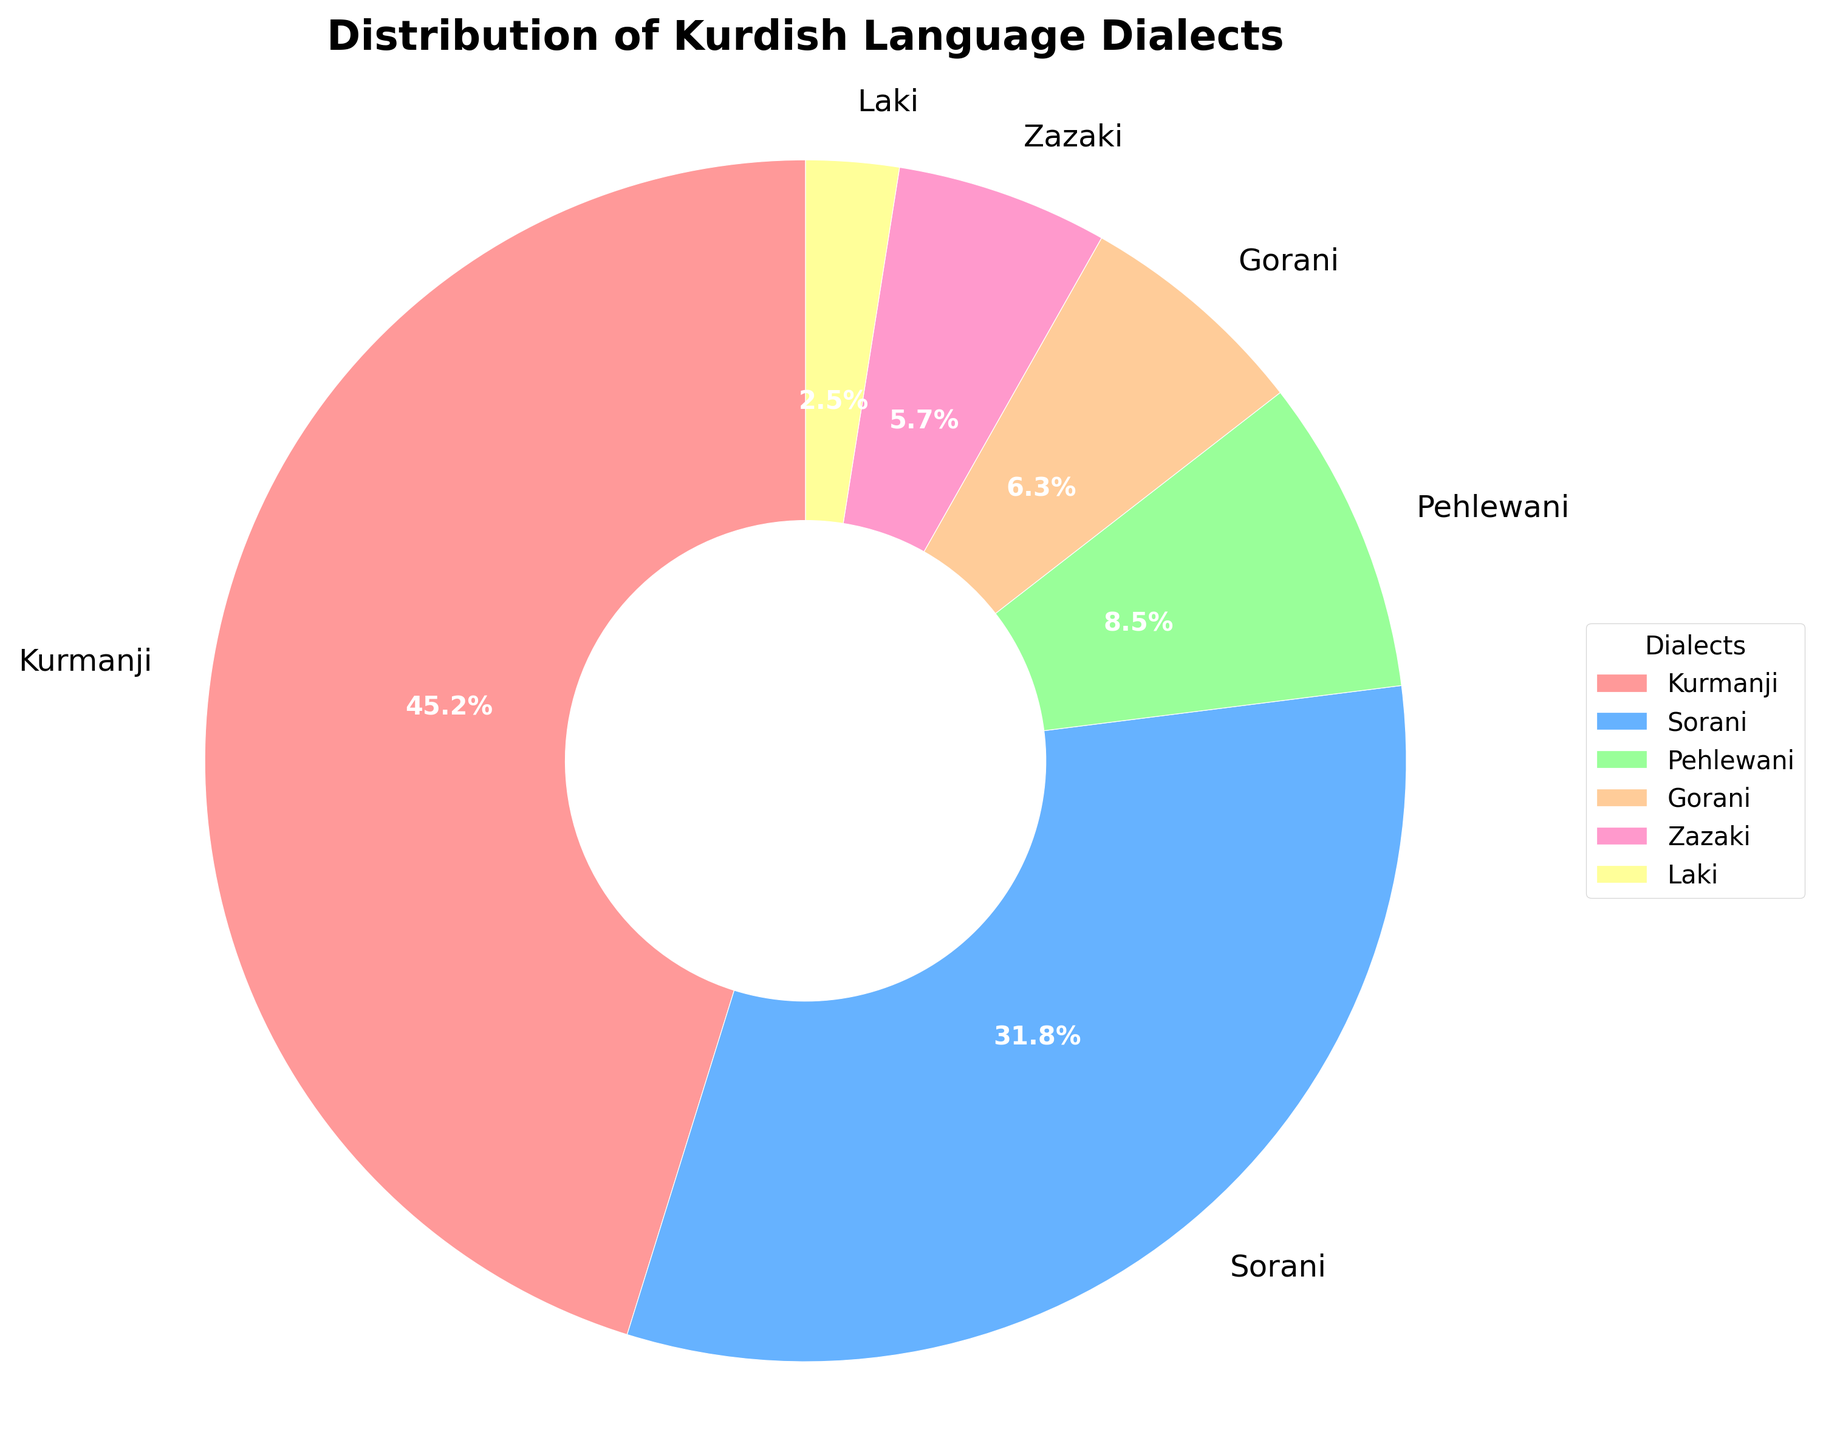What percentage of speakers speak either Kurmanji or Sorani dialects? To find the percentage of people who speak either Kurmanji or Sorani, we add the percentages of both dialects together. Kurmanji is 45.2% and Sorani is 31.8%. Therefore, 45.2 + 31.8 = 77.0%.
Answer: 77.0% Which dialect is spoken by the smallest percentage of people? By looking at the provided percentages, Laki has the smallest percentage at 2.5%.
Answer: Laki Which dialect is spoken more, Gorani or Zazaki? Compare the percentages of Gorani (6.3%) and Zazaki (5.7%), and Gorani is spoken by a higher percentage of people.
Answer: Gorani How much larger is the percentage of Kurmanji speakers compared to the percentage of Gorani speakers? Subtract the percentage of Gorani speakers from the percentage of Kurmanji speakers: 45.2% (Kurmanji) - 6.3% (Gorani) = 38.9%.
Answer: 38.9% What is the combined percentage of speakers who speak Pehlewani, Gorani, and Zazaki dialects? Sum the percentages of Pehlewani (8.5%), Gorani (6.3%), and Zazaki (5.7%): 8.5 + 6.3 + 5.7 = 20.5%.
Answer: 20.5% Is the percentage of Sorani speakers greater than the combined percentage of Gorani and Zazaki speakers? Compare the percentage of Sorani speakers (31.8%) to the combined percentage of Gorani (6.3%) and Zazaki (5.7%): 6.3 + 5.7 = 12.0%. Since 31.8% is greater than 12.0%, yes, it is greater.
Answer: Yes What is the ratio of Kurmanji speakers to Laki speakers? To find the ratio, divide the percentage of Kurmanji speakers (45.2%) by the percentage of Laki speakers (2.5%): 45.2 / 2.5 = 18.08.
Answer: 18.08 Which dialect is represented by a segment with a light green color? Looking at the visual attributes, the light green segment corresponds to Pehlewani, which is 8.5%.
Answer: Pehlewani Arrange the dialects in descending order of the percentage of speakers. The order from highest to lowest percentage of speakers is: Kurmanji (45.2%), Sorani (31.8%), Pehlewani (8.5%), Gorani (6.3%), Zazaki (5.7%), and Laki (2.5%).
Answer: Kurmanji, Sorani, Pehlewani, Gorani, Zazaki, Laki Is the percentage of Kurmanji speakers more than double the percentage of Sorani speakers? To check, we need to see if 45.2% is more than twice 31.8%. Double 31.8% is 63.6%, and 45.2% is not more than 63.6%, so the answer is no.
Answer: No 